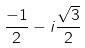Convert formula to latex. <formula><loc_0><loc_0><loc_500><loc_500>\frac { - 1 } { 2 } - i \frac { \sqrt { 3 } } { 2 }</formula> 